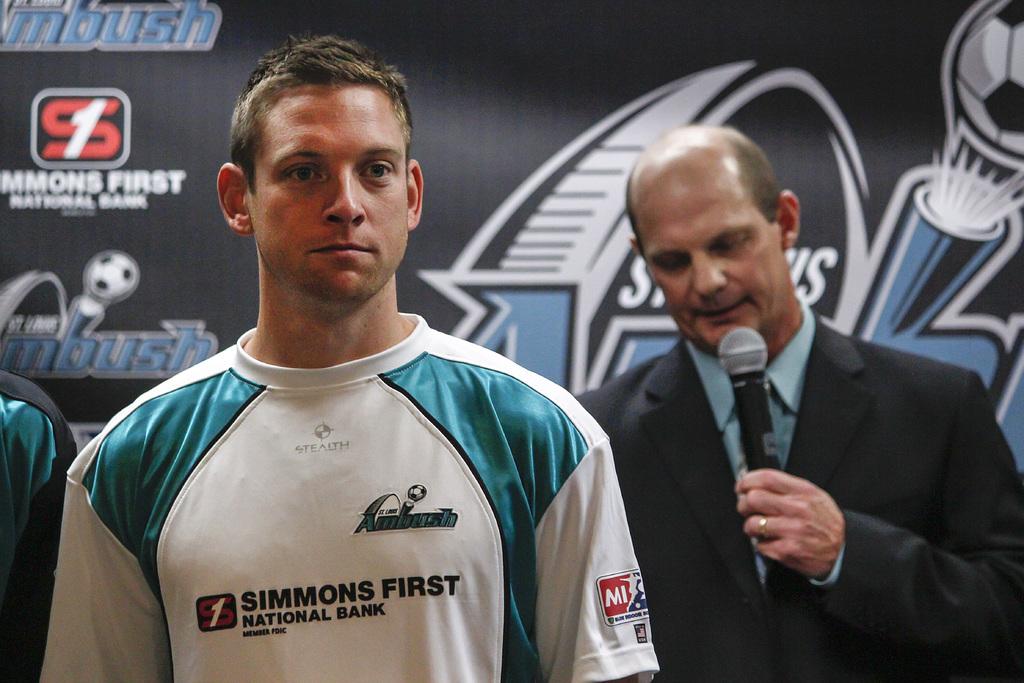What is simmons first?
Ensure brevity in your answer.  National bank. 